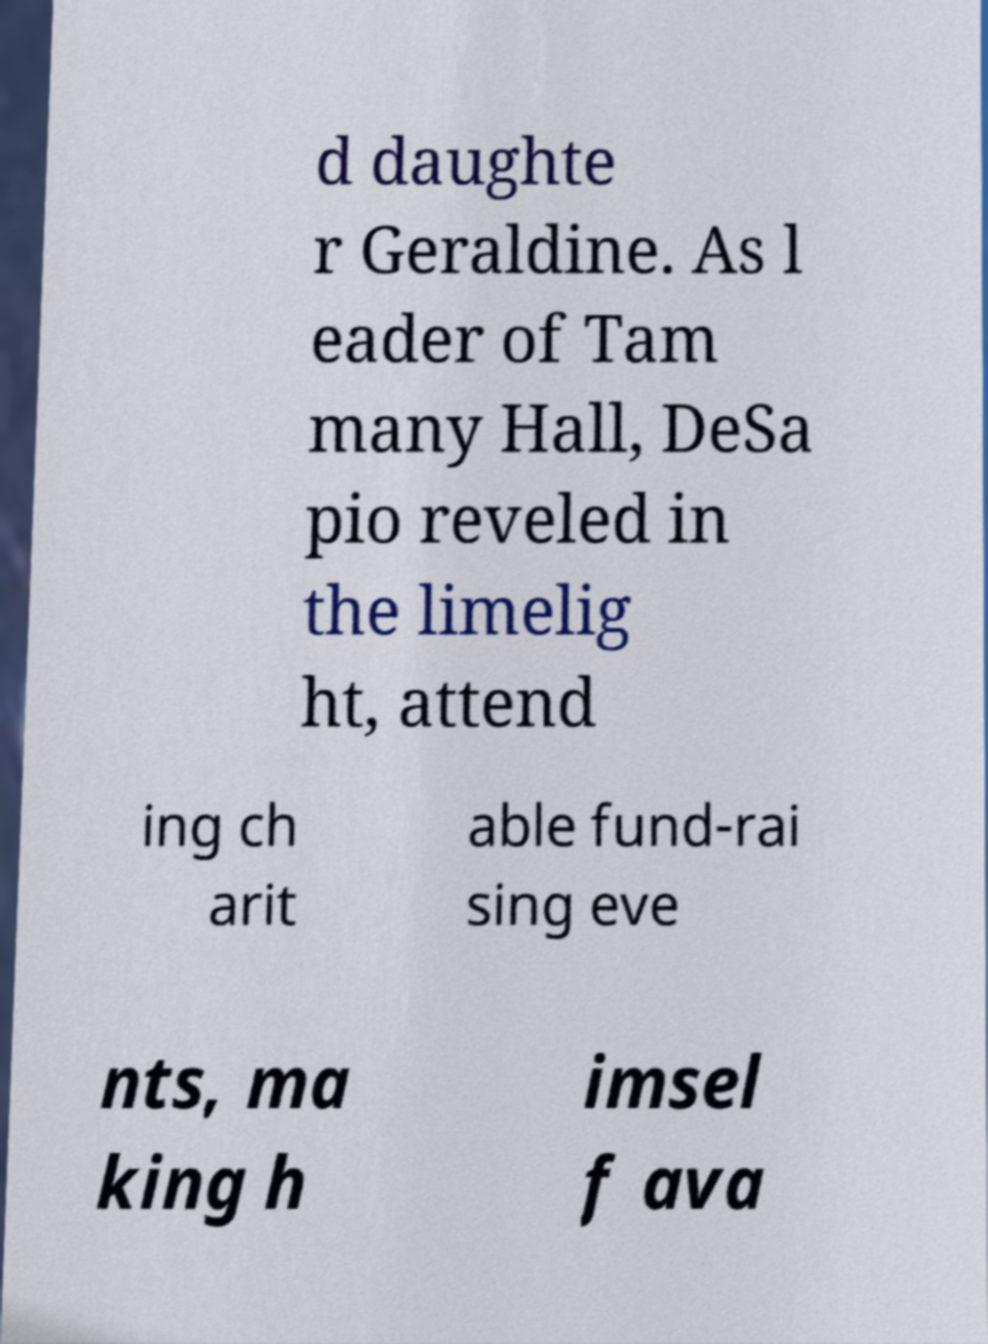Can you read and provide the text displayed in the image?This photo seems to have some interesting text. Can you extract and type it out for me? d daughte r Geraldine. As l eader of Tam many Hall, DeSa pio reveled in the limelig ht, attend ing ch arit able fund-rai sing eve nts, ma king h imsel f ava 